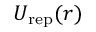<formula> <loc_0><loc_0><loc_500><loc_500>U _ { r e p } ( r )</formula> 